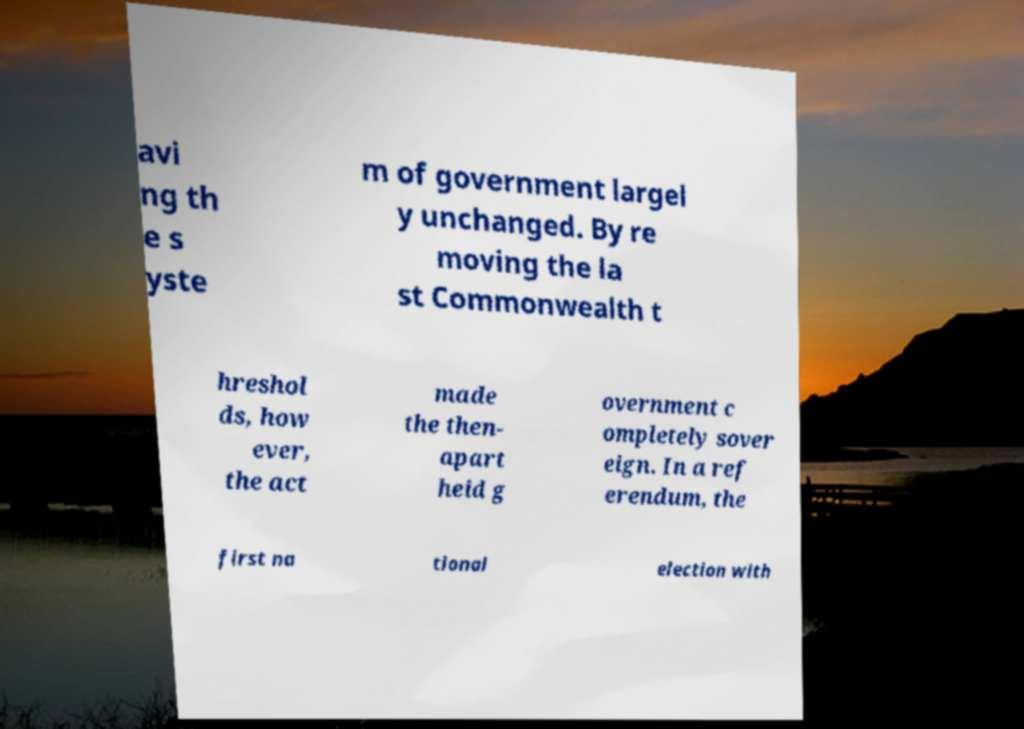For documentation purposes, I need the text within this image transcribed. Could you provide that? avi ng th e s yste m of government largel y unchanged. By re moving the la st Commonwealth t hreshol ds, how ever, the act made the then- apart heid g overnment c ompletely sover eign. In a ref erendum, the first na tional election with 